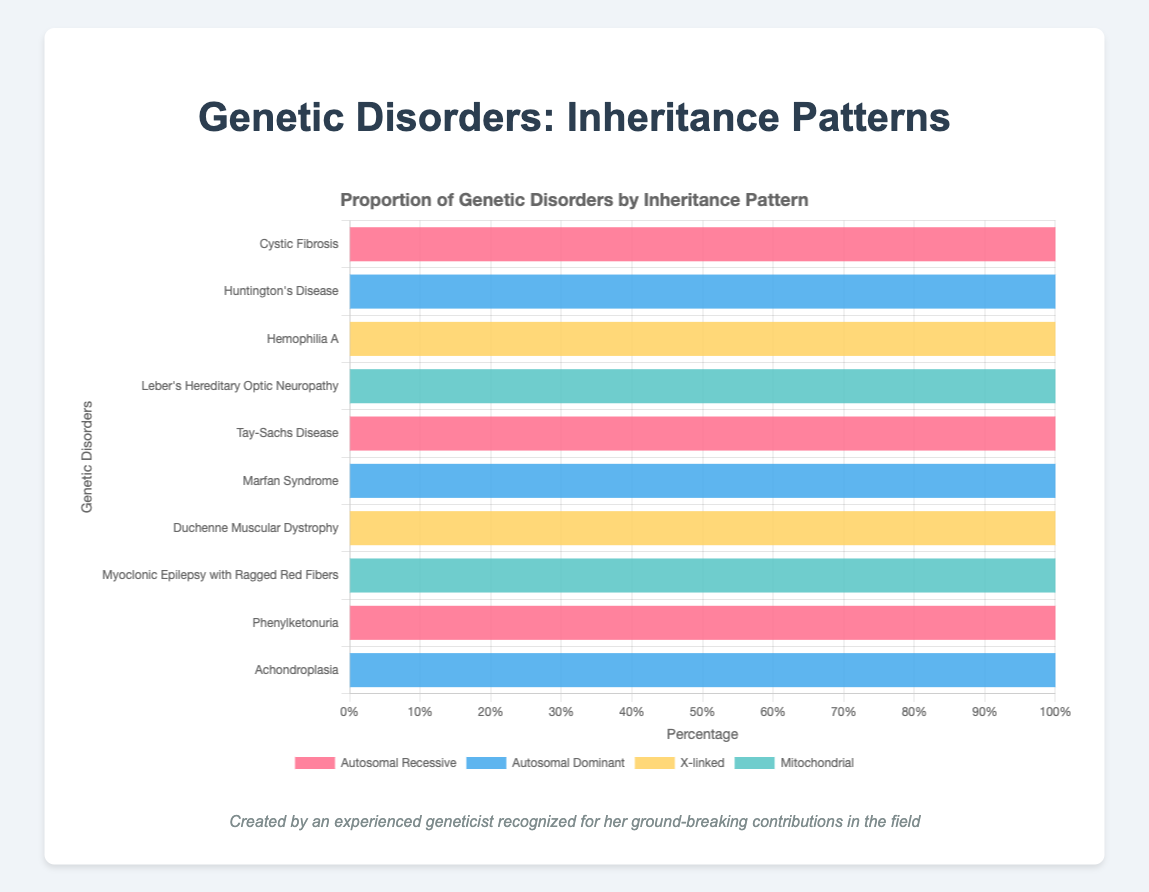Which genetic disorder is represented by the blue segment? The blue segment represents the data for Autosomal Dominant inheritance pattern. Looking at the bar with a blue segment, we can see Huntington's Disease, Marfan Syndrome, and Achondroplasia are represented by the blue segment.
Answer: Huntington's Disease, Marfan Syndrome, Achondroplasia How many genetic disorders are inherited through a recessive pattern? Autosomal Recessive inheritance patterns are shown in red. The genetic disorders represented by red segments are Cystic Fibrosis, Tay-Sachs Disease, and Phenylketonuria, totaling 3.
Answer: 3 Which genetic disorders fall into an X-linked inheritance pattern? X-linked inheritance patterns are shown in yellow. The genetic disorders with yellow segments are Hemophilia A and Duchenne Muscular Dystrophy.
Answer: Hemophilia A, Duchenne Muscular Dystrophy Which inheritance pattern has the least number of associated disorders, and what are they? By counting the segments, Mitochondrial inheritance (green) is associated with the least number of disorders. The disorders with green segments are Leber's Hereditary Optic Neuropathy and Myoclonic Epilepsy with Ragged Red Fibers.
Answer: Mitochondrial; Leber's Hereditary Optic Neuropathy, Myoclonic Epilepsy with Ragged Red Fibers Are there any genetic disorders that are not inherited through an autosomal dominant pattern? Autosomal Dominant inheritance patterns are shown in blue. Any disorder without blue is not inherited through an autosomal dominant pattern. The disorders that are not blue are Cystic Fibrosis, Hemophilia A, Leber's Hereditary Optic Neuropathy, Tay-Sachs Disease, Duchenne Muscular Dystrophy, Myoclonic Epilepsy with Ragged Red Fibers, and Phenylketonuria.
Answer: Cystic Fibrosis, Hemophilia A, Leber's Hereditary Optic Neuropathy, Tay-Sachs Disease, Duchenne Muscular Dystrophy, Myoclonic Epilepsy with Ragged Red Fibers, Phenylketonuria Which disorder is represented entirely by the green segment? The green segment represents the mitochondrial inheritance pattern. Leber's Hereditary Optic Neuropathy and Myoclonic Epilepsy with Ragged Red Fibers are represented by green segments.
Answer: Leber's Hereditary Optic Neuropathy, Myoclonic Epilepsy with Ragged Red Fibers Which disorder has a 100% autosomal dominant inheritance? The blue segment represents autosomal dominant inheritance. The disorders entirely represented by blue are Huntington's Disease, Marfan Syndrome, and Achondroplasia.
Answer: Huntington's Disease, Marfan Syndrome, Achondroplasia What's the difference in the number of disorders between the autosomal recessive and the X-linked inheritance patterns? - Identify the number of disorders for each inheritance pattern: Autosomal Recessive (red) has Cystic Fibrosis, Tay-Sachs Disease, and Phenylketonuria, totaling 3. X-linked (yellow) has Hemophilia A and Duchenne Muscular Dystrophy, totaling 2. 
- Calculate the difference: 3 - 2 = 1.
Answer: 1 What's the total number of genetic disorders represented in the figure? Count the total number of disorders listed in the chart: Cystic Fibrosis, Huntington's Disease, Hemophilia A, Leber's Hereditary Optic Neuropathy, Tay-Sachs Disease, Marfan Syndrome, Duchenne Muscular Dystrophy, Myoclonic Epilepsy with Ragged Red Fibers, Phenylketonuria, Achondroplasia. This totals 10 disorders.
Answer: 10 